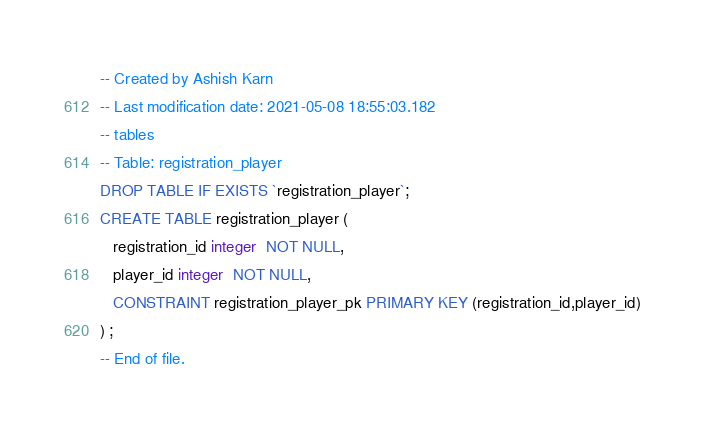Convert code to text. <code><loc_0><loc_0><loc_500><loc_500><_SQL_>-- Created by Ashish Karn
-- Last modification date: 2021-05-08 18:55:03.182
-- tables
-- Table: registration_player
DROP TABLE IF EXISTS `registration_player`;
CREATE TABLE registration_player (
   registration_id integer  NOT NULL,
   player_id integer  NOT NULL,
   CONSTRAINT registration_player_pk PRIMARY KEY (registration_id,player_id)
) ;
-- End of file.</code> 